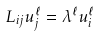Convert formula to latex. <formula><loc_0><loc_0><loc_500><loc_500>L _ { i j } u ^ { \ell } _ { j } = \lambda ^ { \ell } u ^ { \ell } _ { i }</formula> 